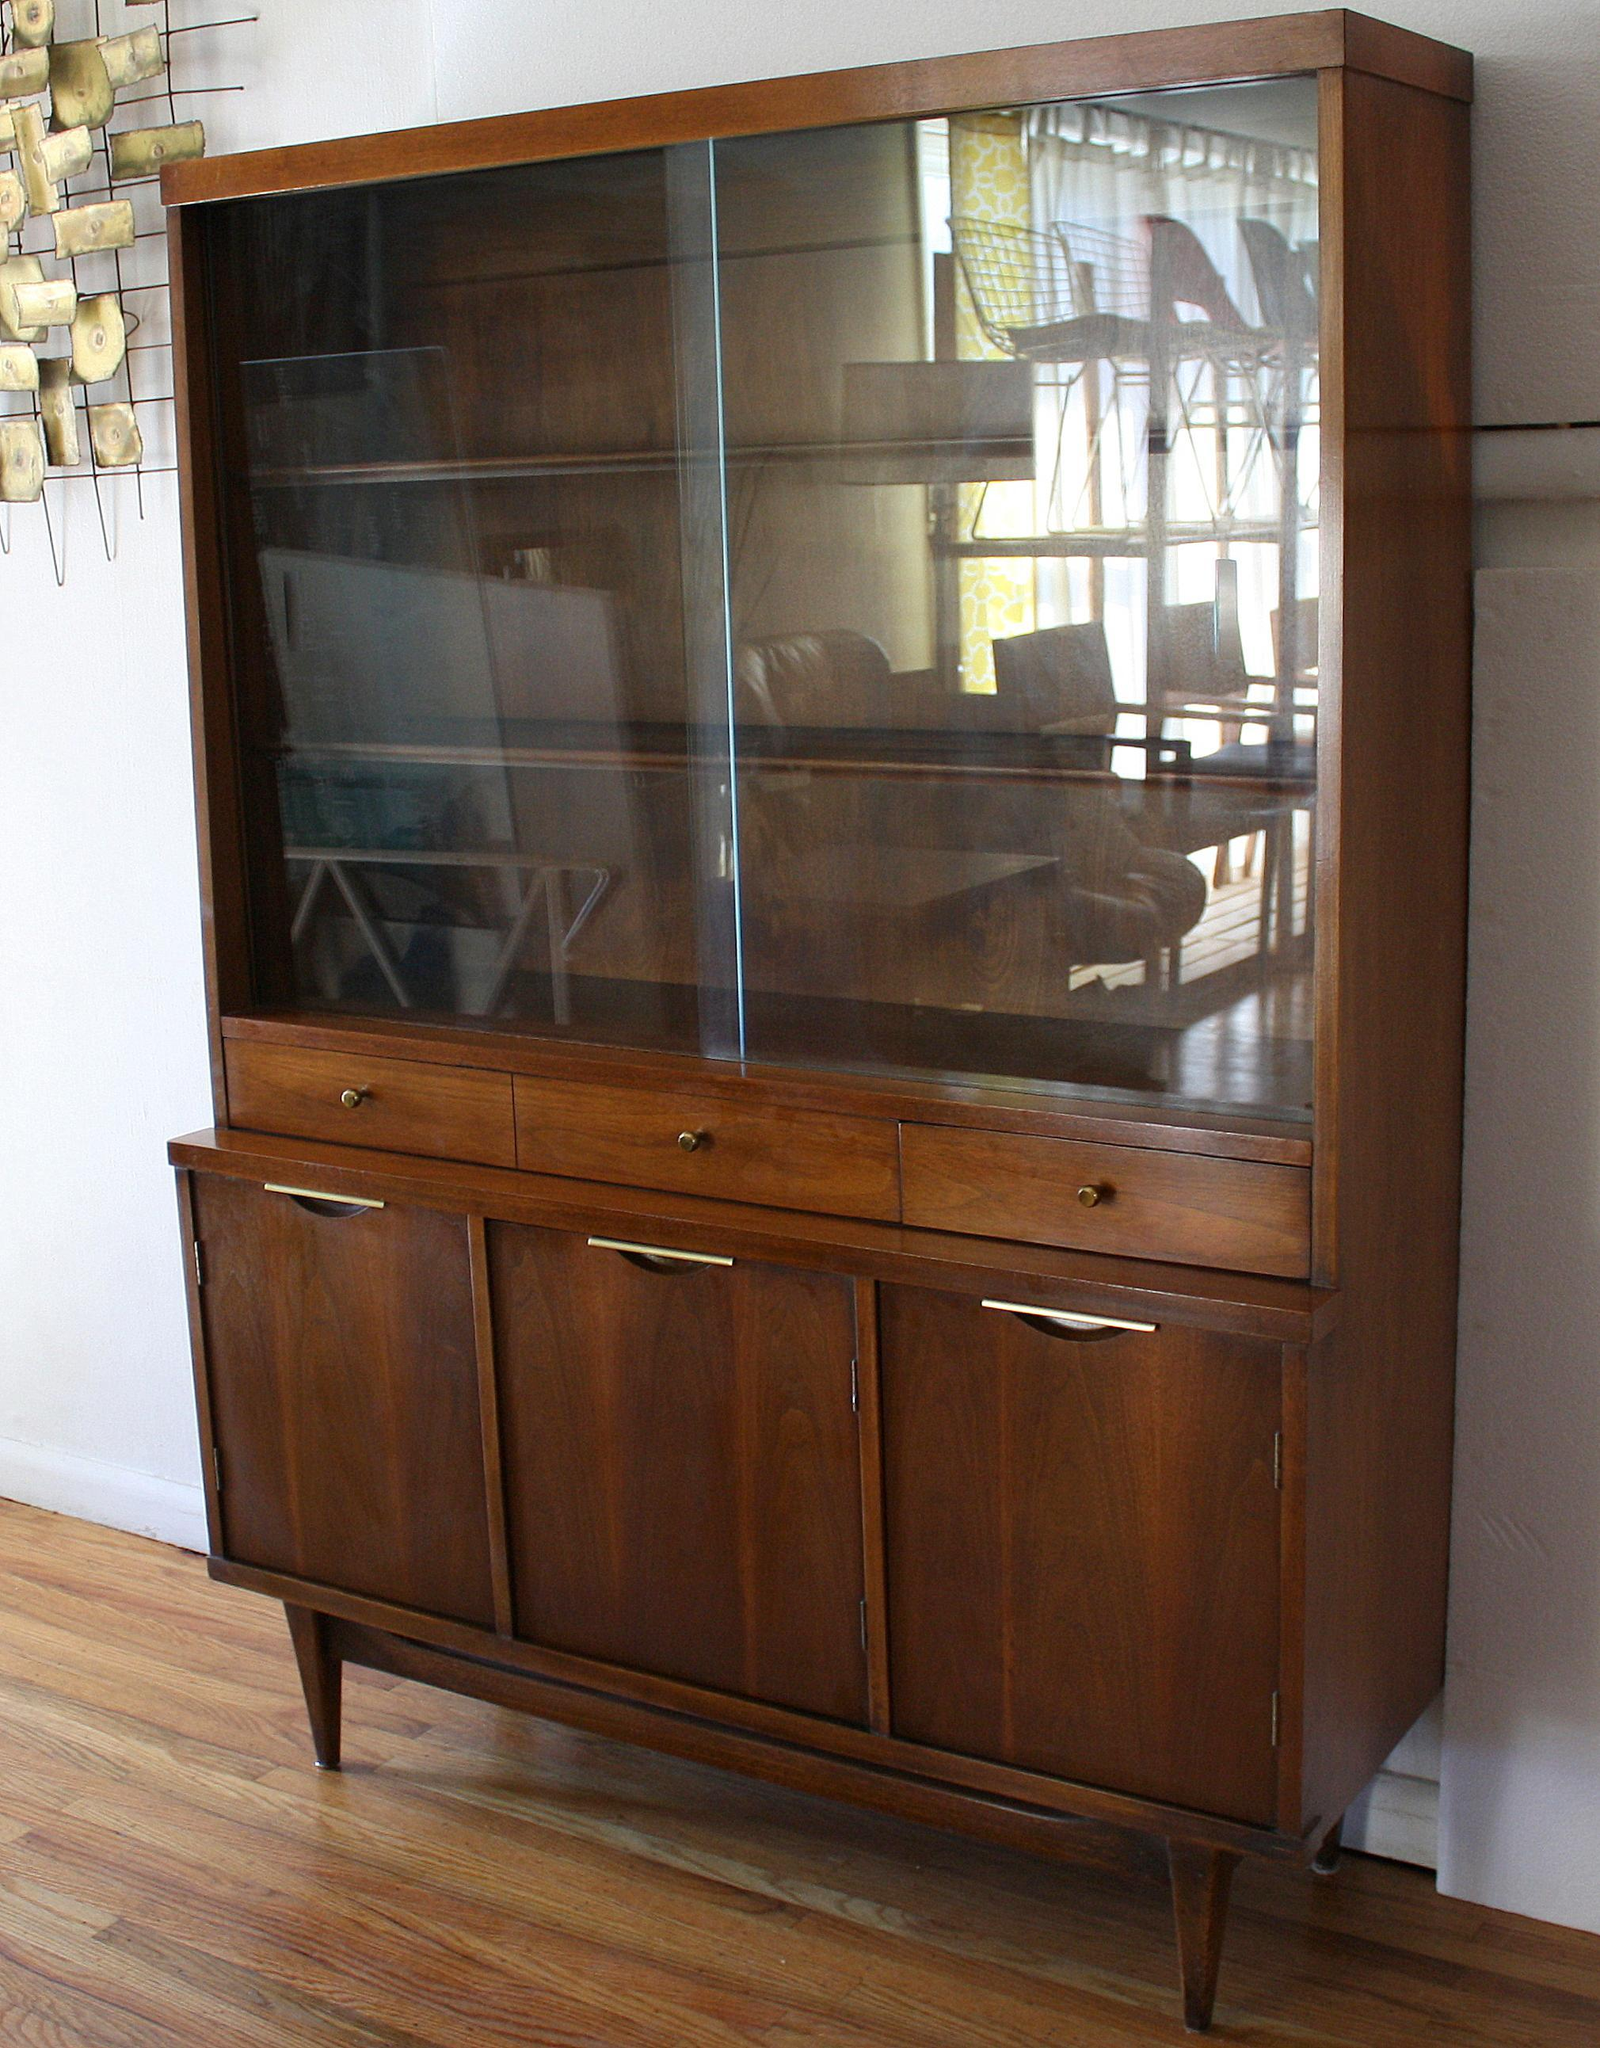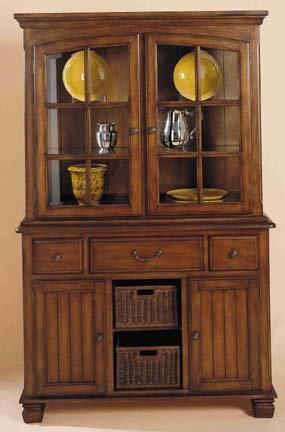The first image is the image on the left, the second image is the image on the right. Considering the images on both sides, is "At least one of the cabinets has no legs and sits flush on the floor." valid? Answer yes or no. No. 